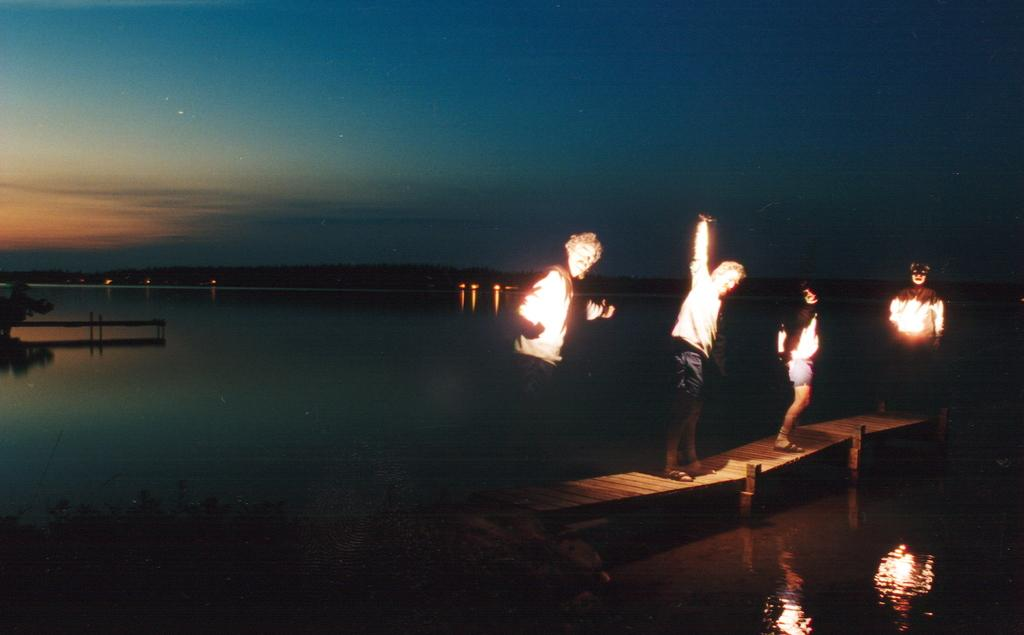What is the main setting of the image? There are people on a platform in the image. What can be seen in the background of the image? The sky is visible in the background of the image. What is the purpose of the lights in the image? The lights provide illumination in the image. What objects are present on the platform? There are objects on the platform, but their specific nature is not mentioned in the facts. Can you describe the water visible in the image? The facts only mention that water is visible in the image, but its characteristics or location are not specified. What relation does the drop of water have with the people on the platform? There is no mention of a drop of water in the image or any relation between the water and the people on the platform. 